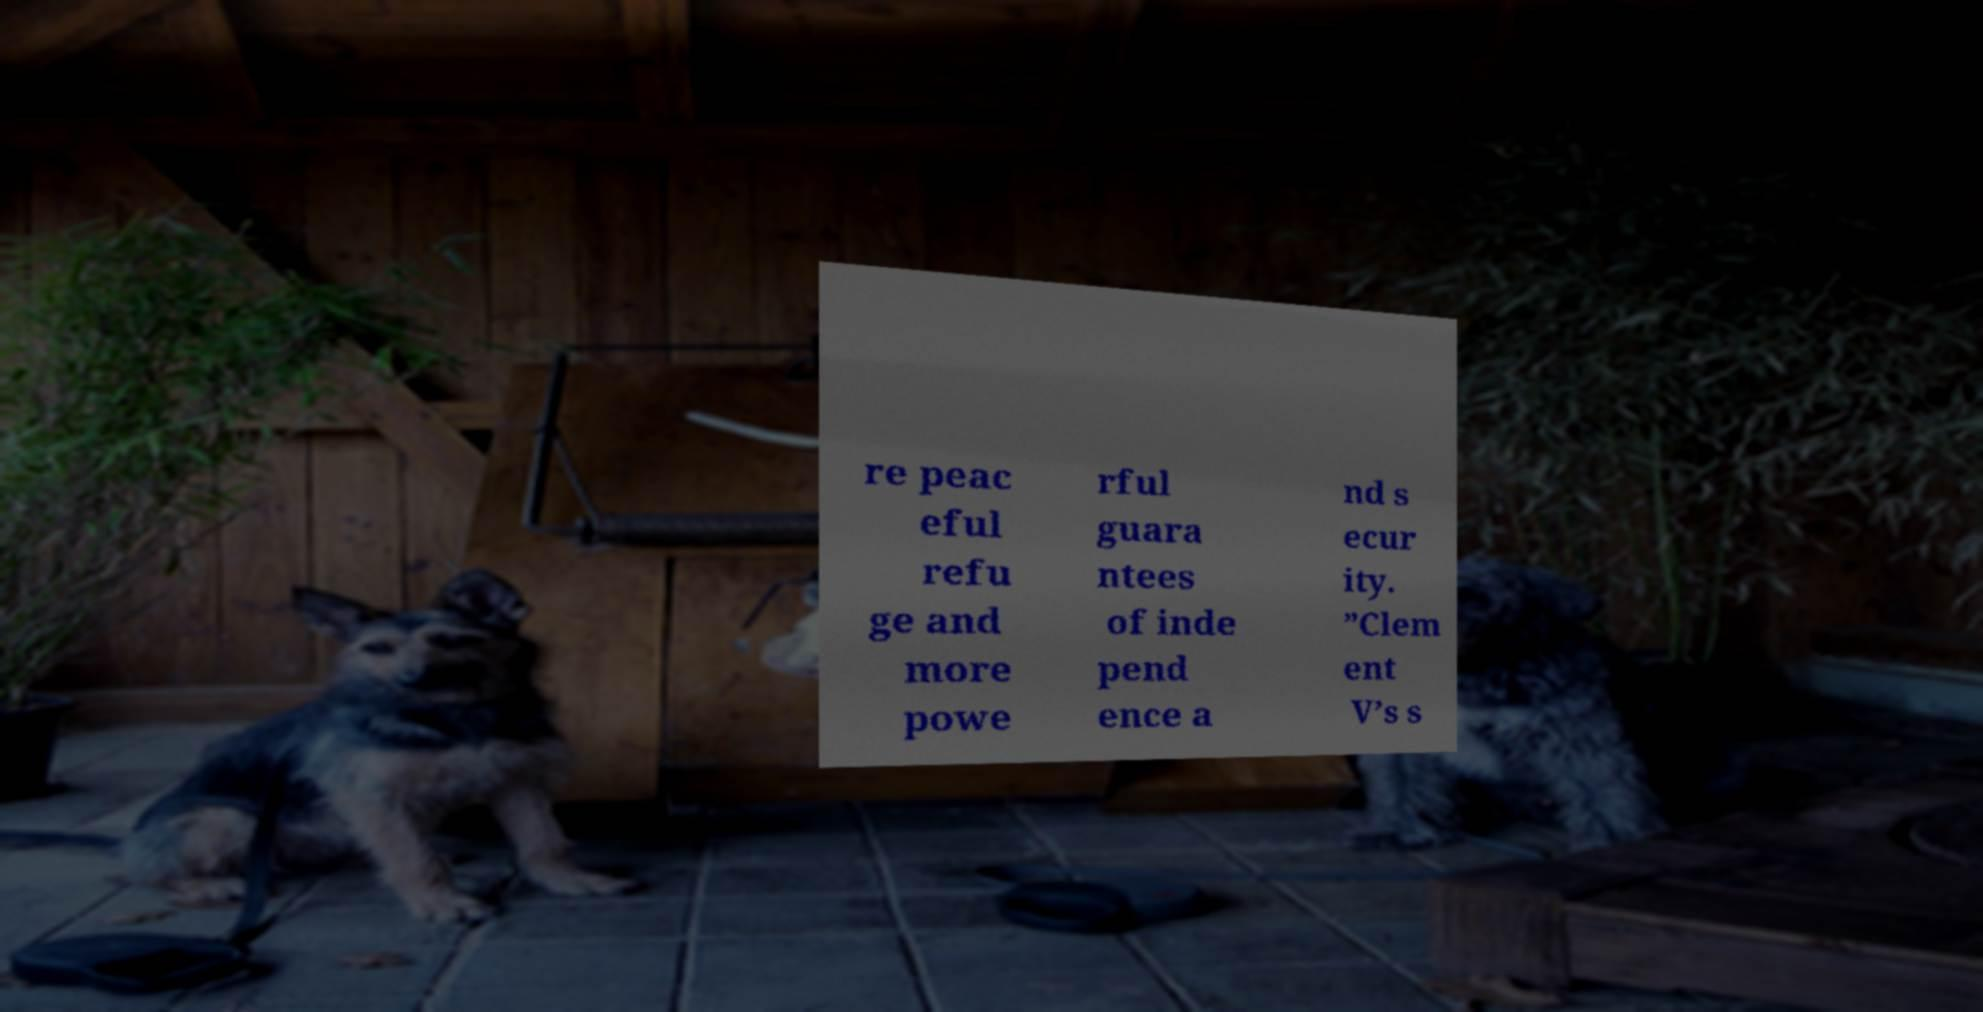Could you extract and type out the text from this image? re peac eful refu ge and more powe rful guara ntees of inde pend ence a nd s ecur ity. ”Clem ent V’s s 